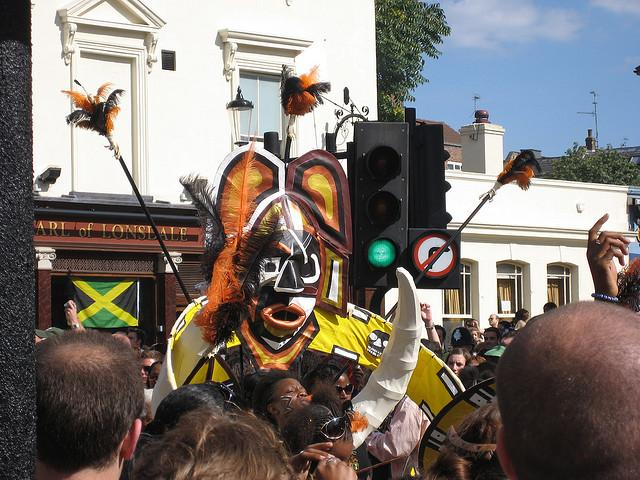What does the color of traffic light in the above picture imply to road users?

Choices:
A) give way
B) go
C) wait
D) stop go 